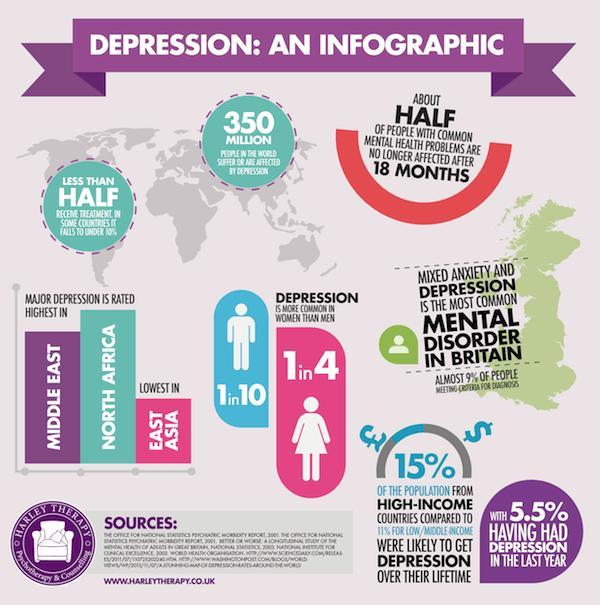How much more % people in high-income countries were able to be get over depression when compared to low/middle income countries
Answer the question with a short phrase. 4 Which region is rated highest in depression North Africa How many people in the world suffer from depression 350 million What % of women are affected by depression 25 What % of men are affected by depression 10 